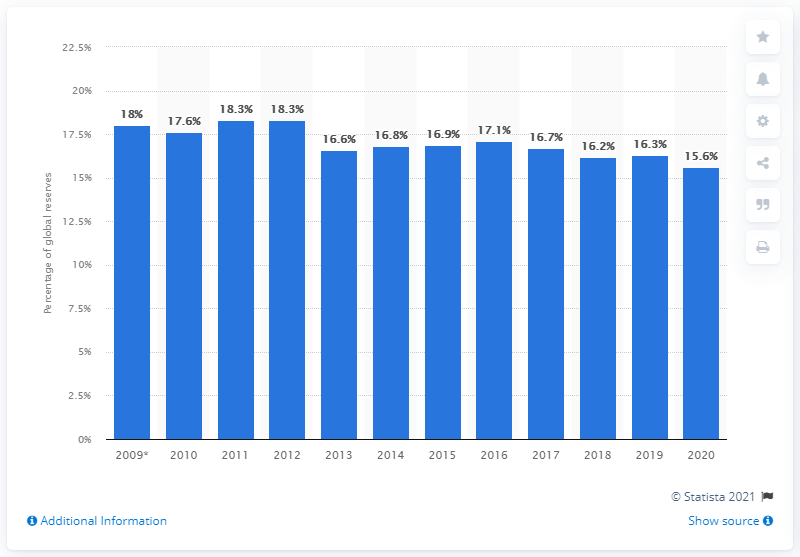Give some essential details in this illustration. In 2020, Gazprom held 15.6% of the world's natural gas reserves. 